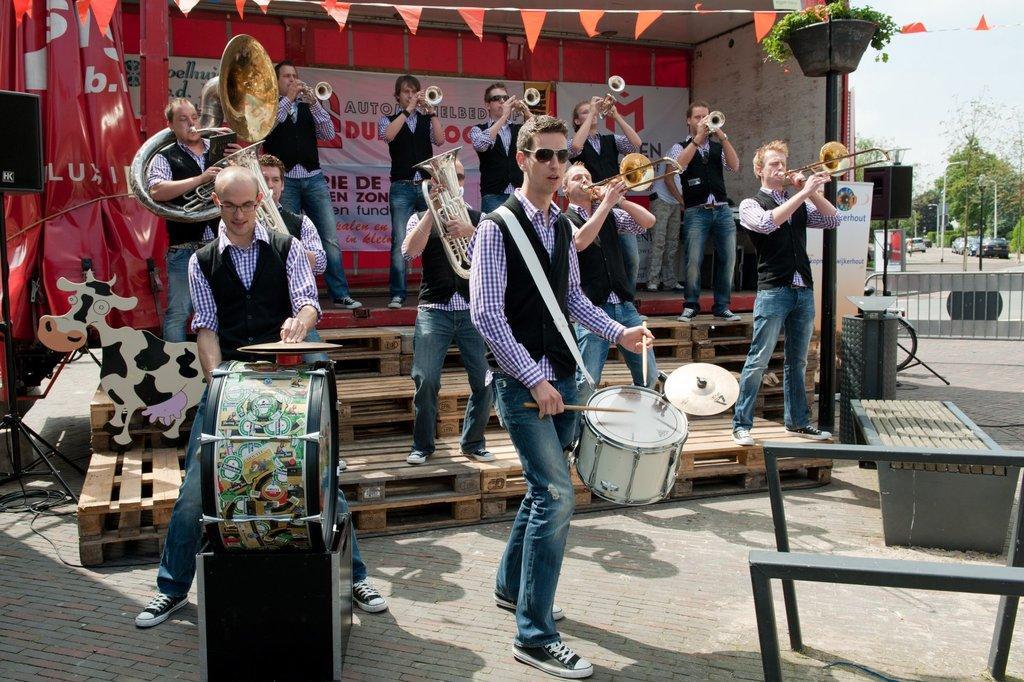How would you summarize this image in a sentence or two? In this image I see men who are holding the musical instruments in their hands, I can also see speakers, a bench and a plant over here. In the background I see the trees, cars on the path and few poles. 